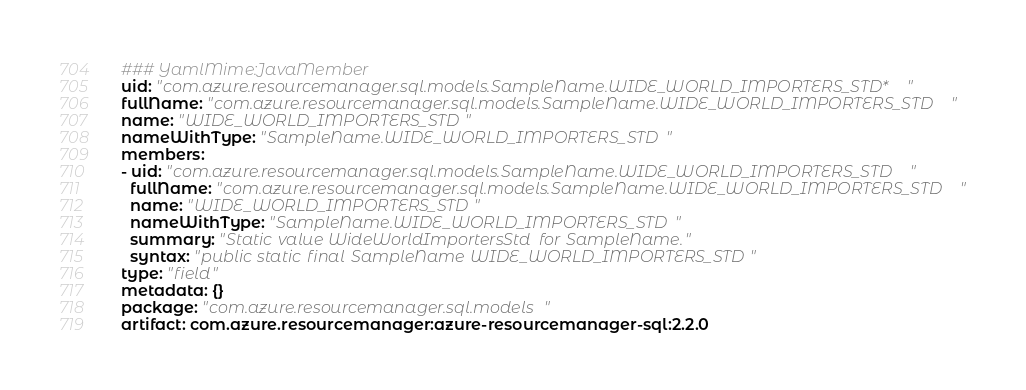Convert code to text. <code><loc_0><loc_0><loc_500><loc_500><_YAML_>### YamlMime:JavaMember
uid: "com.azure.resourcemanager.sql.models.SampleName.WIDE_WORLD_IMPORTERS_STD*"
fullName: "com.azure.resourcemanager.sql.models.SampleName.WIDE_WORLD_IMPORTERS_STD"
name: "WIDE_WORLD_IMPORTERS_STD"
nameWithType: "SampleName.WIDE_WORLD_IMPORTERS_STD"
members:
- uid: "com.azure.resourcemanager.sql.models.SampleName.WIDE_WORLD_IMPORTERS_STD"
  fullName: "com.azure.resourcemanager.sql.models.SampleName.WIDE_WORLD_IMPORTERS_STD"
  name: "WIDE_WORLD_IMPORTERS_STD"
  nameWithType: "SampleName.WIDE_WORLD_IMPORTERS_STD"
  summary: "Static value WideWorldImportersStd for SampleName."
  syntax: "public static final SampleName WIDE_WORLD_IMPORTERS_STD"
type: "field"
metadata: {}
package: "com.azure.resourcemanager.sql.models"
artifact: com.azure.resourcemanager:azure-resourcemanager-sql:2.2.0
</code> 